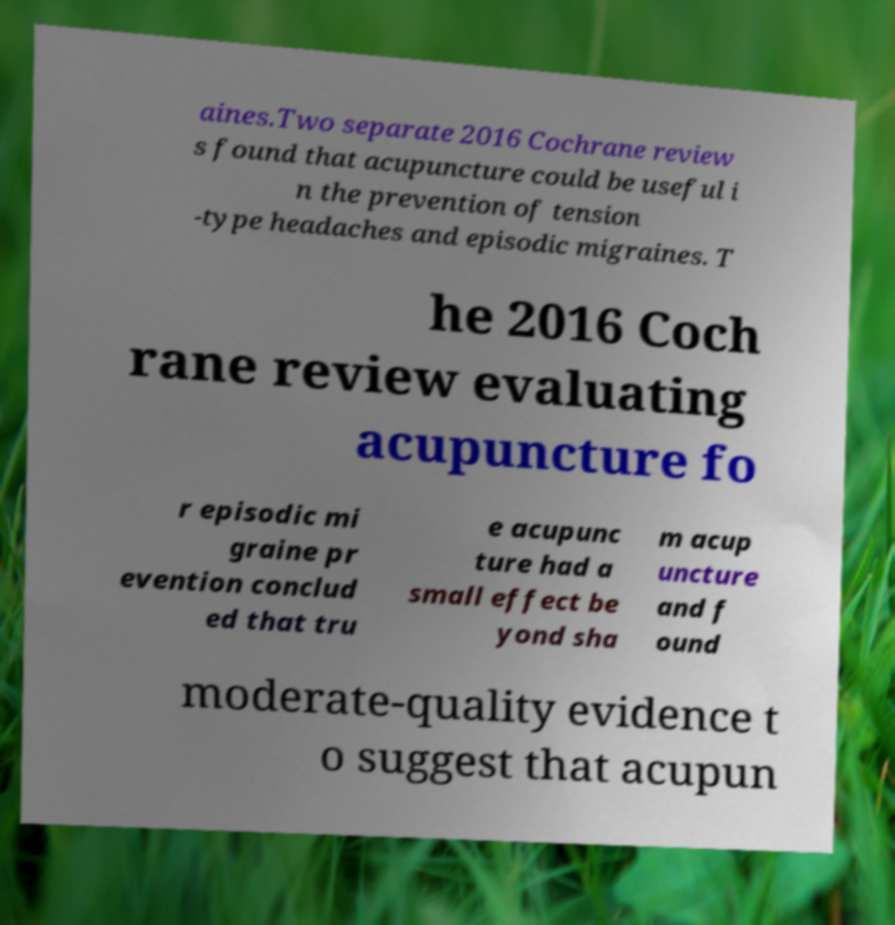There's text embedded in this image that I need extracted. Can you transcribe it verbatim? aines.Two separate 2016 Cochrane review s found that acupuncture could be useful i n the prevention of tension -type headaches and episodic migraines. T he 2016 Coch rane review evaluating acupuncture fo r episodic mi graine pr evention conclud ed that tru e acupunc ture had a small effect be yond sha m acup uncture and f ound moderate-quality evidence t o suggest that acupun 